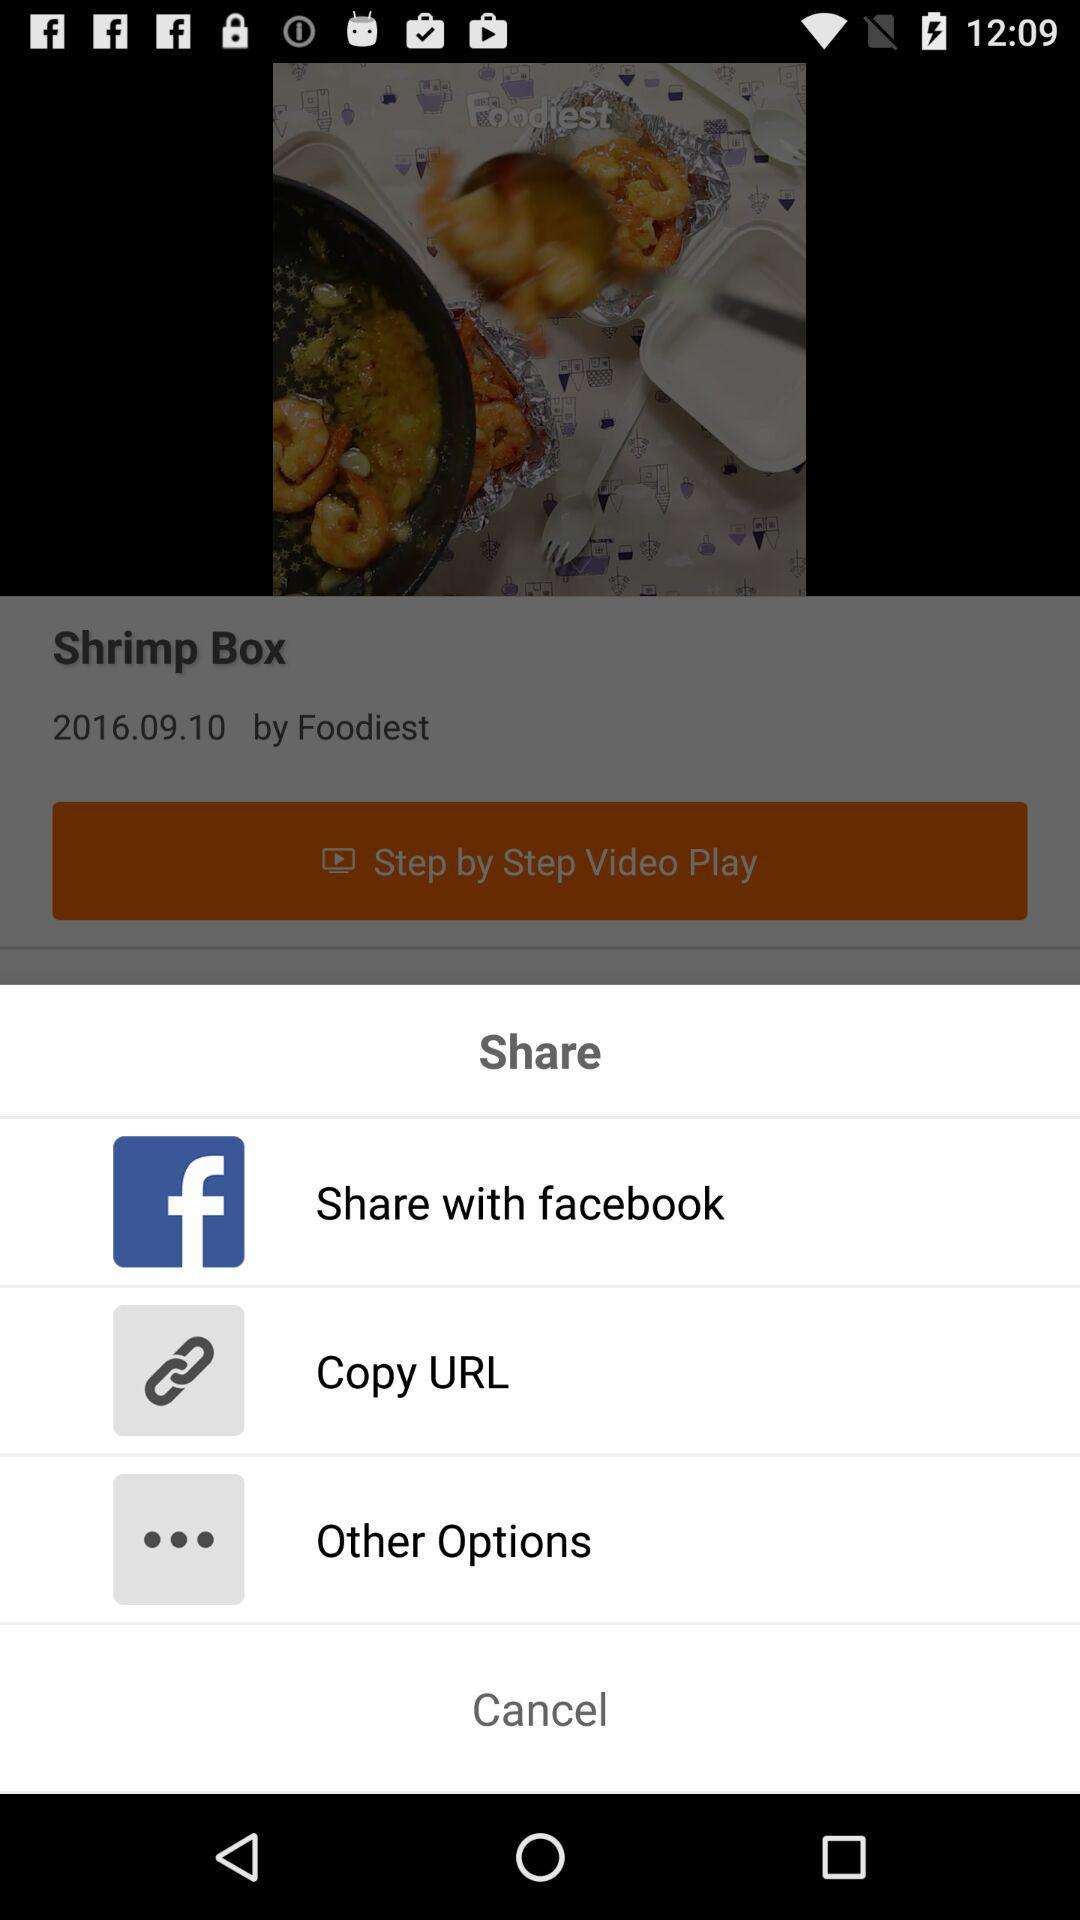How many items are in the share menu?
Answer the question using a single word or phrase. 3 